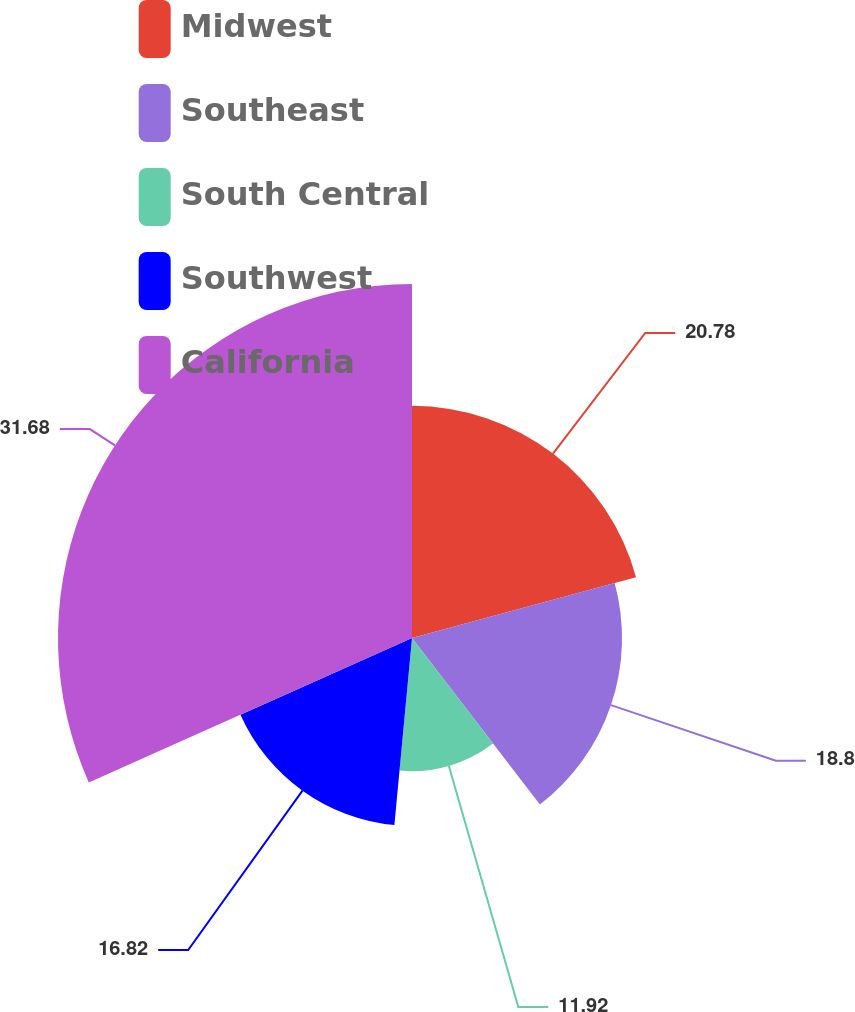Convert chart. <chart><loc_0><loc_0><loc_500><loc_500><pie_chart><fcel>Midwest<fcel>Southeast<fcel>South Central<fcel>Southwest<fcel>California<nl><fcel>20.78%<fcel>18.8%<fcel>11.92%<fcel>16.82%<fcel>31.69%<nl></chart> 